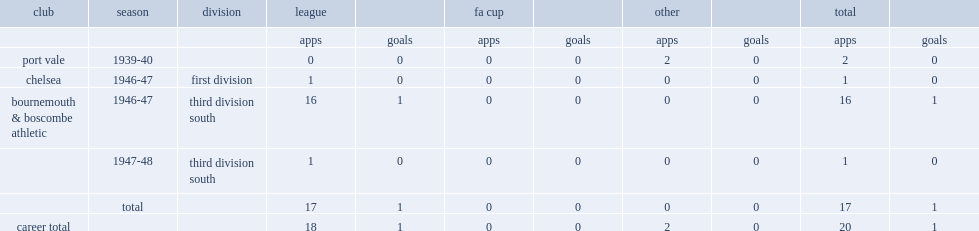Give me the full table as a dictionary. {'header': ['club', 'season', 'division', 'league', '', 'fa cup', '', 'other', '', 'total', ''], 'rows': [['', '', '', 'apps', 'goals', 'apps', 'goals', 'apps', 'goals', 'apps', 'goals'], ['port vale', '1939-40', '', '0', '0', '0', '0', '2', '0', '2', '0'], ['chelsea', '1946-47', 'first division', '1', '0', '0', '0', '0', '0', '1', '0'], ['bournemouth & boscombe athletic', '1946-47', 'third division south', '16', '1', '0', '0', '0', '0', '16', '1'], ['', '1947-48', 'third division south', '1', '0', '0', '0', '0', '0', '1', '0'], ['', 'total', '', '17', '1', '0', '0', '0', '0', '17', '1'], ['career total', '', '', '18', '1', '0', '0', '2', '0', '20', '1']]} How many games did murdoch dickie play for chelsea in 1946-47? 1.0. 